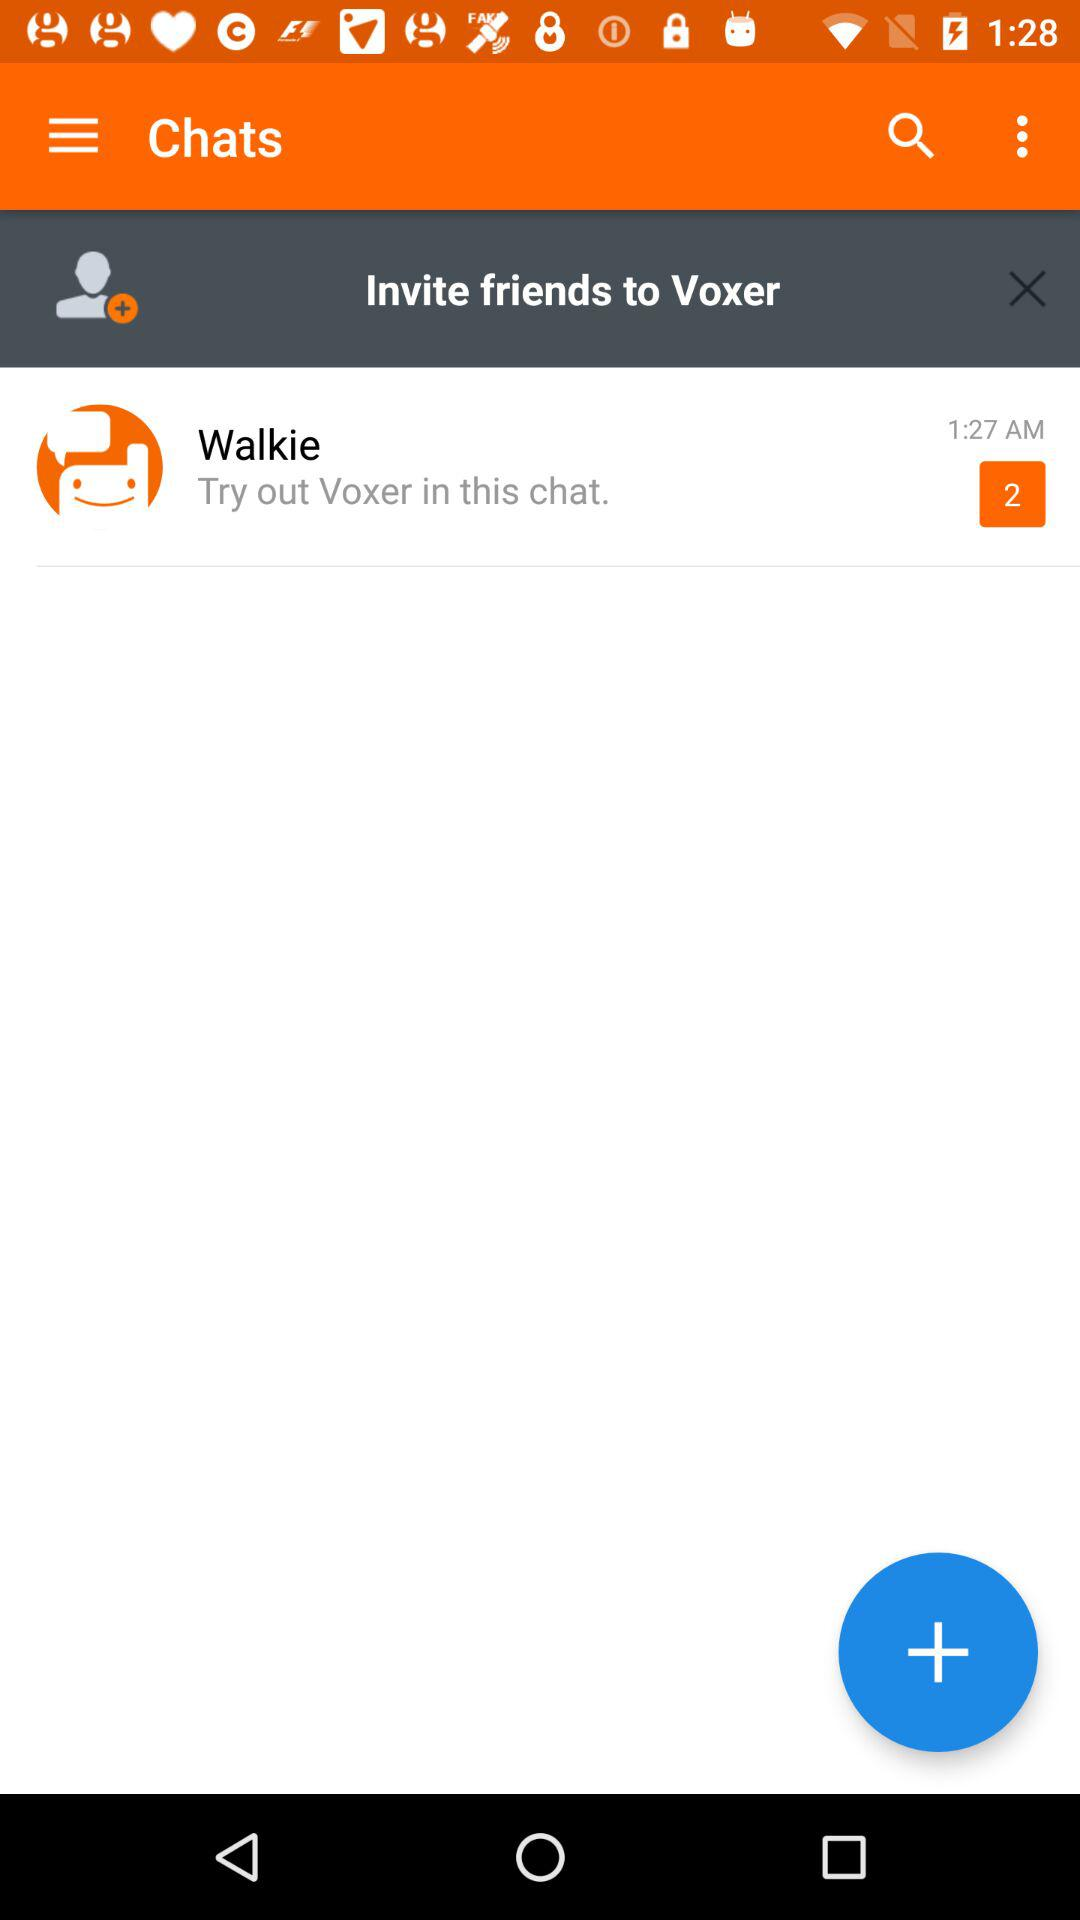How many friends can be invited to "Voxer"?
When the provided information is insufficient, respond with <no answer>. <no answer> 